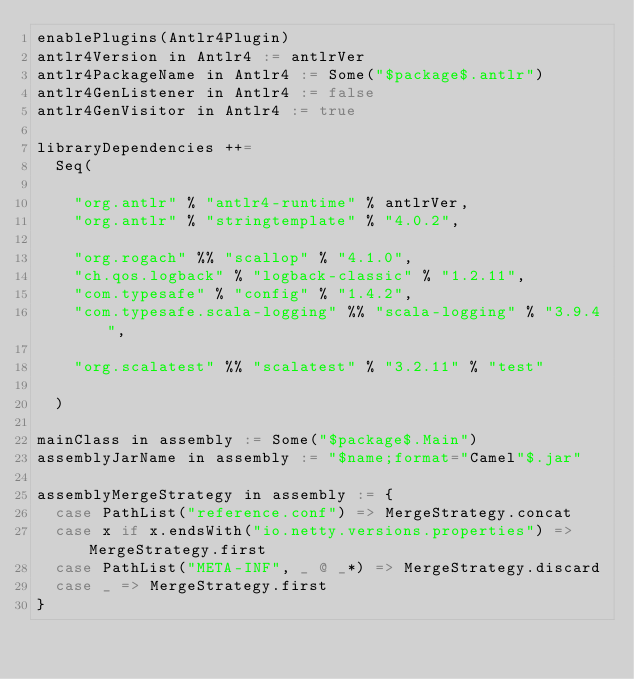<code> <loc_0><loc_0><loc_500><loc_500><_Scala_>enablePlugins(Antlr4Plugin)
antlr4Version in Antlr4 := antlrVer
antlr4PackageName in Antlr4 := Some("$package$.antlr")
antlr4GenListener in Antlr4 := false
antlr4GenVisitor in Antlr4 := true

libraryDependencies ++=
  Seq(

    "org.antlr" % "antlr4-runtime" % antlrVer,
    "org.antlr" % "stringtemplate" % "4.0.2",

    "org.rogach" %% "scallop" % "4.1.0",
    "ch.qos.logback" % "logback-classic" % "1.2.11",
    "com.typesafe" % "config" % "1.4.2",
    "com.typesafe.scala-logging" %% "scala-logging" % "3.9.4",

    "org.scalatest" %% "scalatest" % "3.2.11" % "test"

  )

mainClass in assembly := Some("$package$.Main")
assemblyJarName in assembly := "$name;format="Camel"$.jar"

assemblyMergeStrategy in assembly := {
  case PathList("reference.conf") => MergeStrategy.concat
  case x if x.endsWith("io.netty.versions.properties") => MergeStrategy.first
  case PathList("META-INF", _ @ _*) => MergeStrategy.discard
  case _ => MergeStrategy.first
}

</code> 